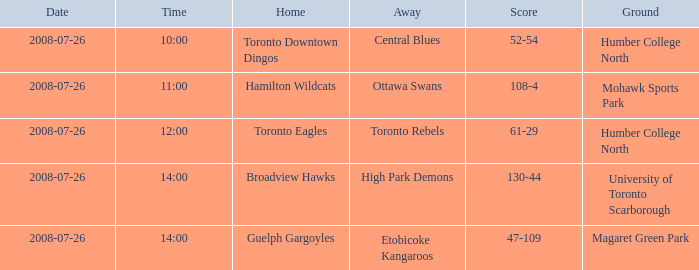Who owns the home score of 52-54? Toronto Downtown Dingos. 